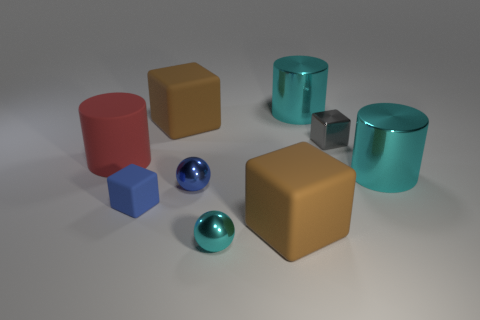Are there any other things that are the same shape as the small matte thing?
Offer a terse response. Yes. How many big cyan objects are in front of the tiny cyan thing?
Give a very brief answer. 0. Are there an equal number of cubes that are on the right side of the gray object and cyan cylinders?
Your answer should be compact. No. Do the blue block and the gray block have the same material?
Offer a terse response. No. There is a block that is both to the left of the blue metallic ball and behind the blue metal ball; what is its size?
Provide a short and direct response. Large. How many red shiny blocks have the same size as the gray object?
Your answer should be very brief. 0. What is the size of the cyan thing that is in front of the large cyan metal cylinder that is right of the tiny gray cube?
Provide a succinct answer. Small. Do the tiny shiny thing that is on the left side of the tiny cyan ball and the matte object in front of the tiny blue cube have the same shape?
Make the answer very short. No. There is a thing that is both in front of the tiny blue rubber thing and behind the cyan metal sphere; what color is it?
Make the answer very short. Brown. Is there another matte block that has the same color as the tiny matte block?
Keep it short and to the point. No. 